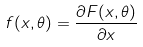Convert formula to latex. <formula><loc_0><loc_0><loc_500><loc_500>f ( x , \theta ) = \frac { \partial F ( x , \theta ) } { \partial x }</formula> 